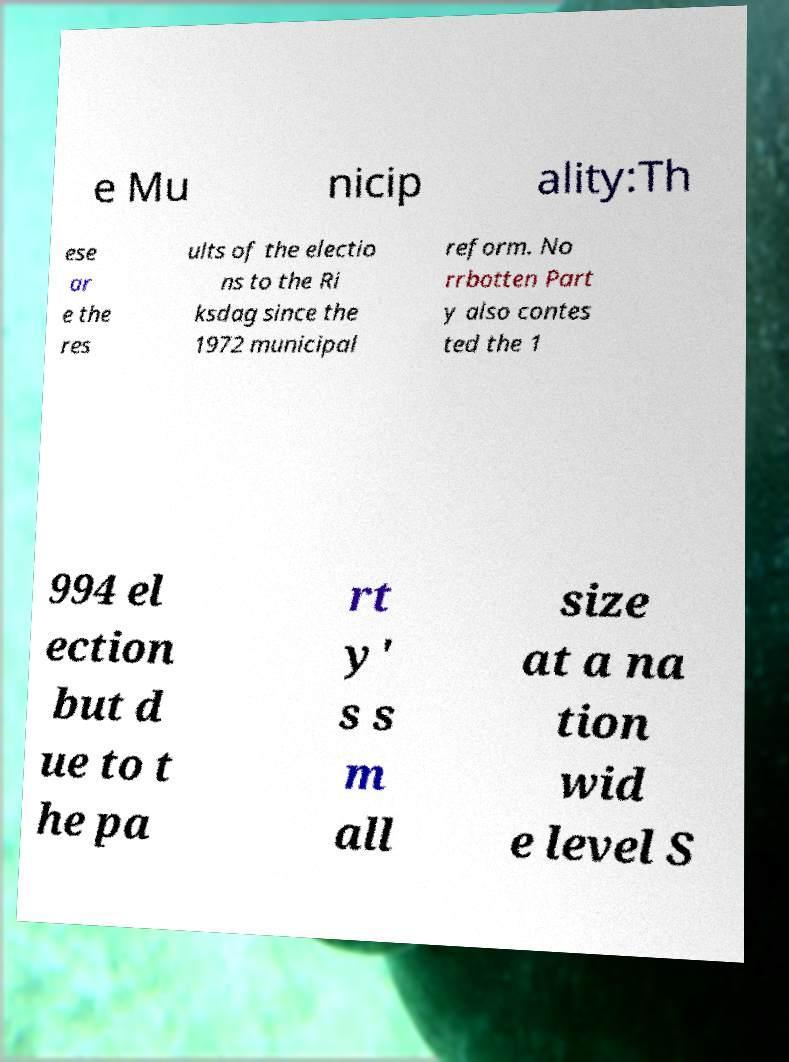There's text embedded in this image that I need extracted. Can you transcribe it verbatim? e Mu nicip ality:Th ese ar e the res ults of the electio ns to the Ri ksdag since the 1972 municipal reform. No rrbotten Part y also contes ted the 1 994 el ection but d ue to t he pa rt y' s s m all size at a na tion wid e level S 